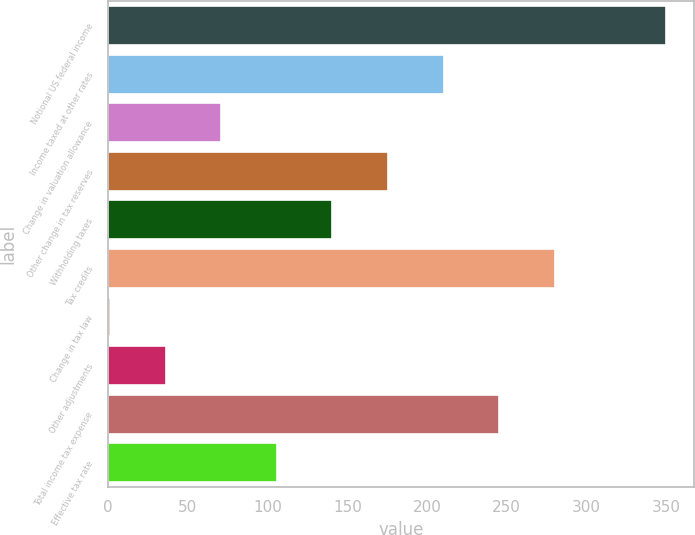Convert chart. <chart><loc_0><loc_0><loc_500><loc_500><bar_chart><fcel>Notional US federal income<fcel>Income taxed at other rates<fcel>Change in valuation allowance<fcel>Other change in tax reserves<fcel>Withholding taxes<fcel>Tax credits<fcel>Change in tax law<fcel>Other adjustments<fcel>Total income tax expense<fcel>Effective tax rate<nl><fcel>350<fcel>210.4<fcel>70.8<fcel>175.5<fcel>140.6<fcel>280.2<fcel>1<fcel>35.9<fcel>245.3<fcel>105.7<nl></chart> 